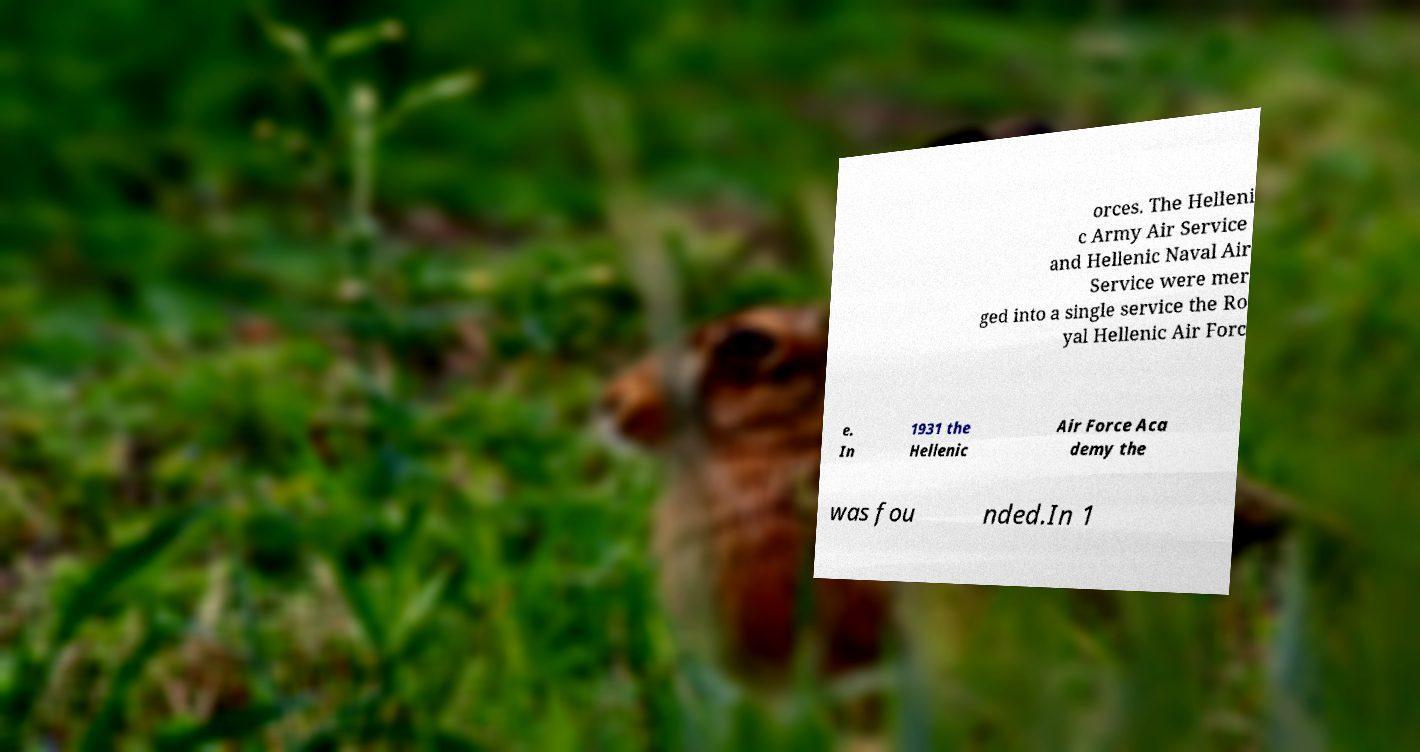Please identify and transcribe the text found in this image. orces. The Helleni c Army Air Service and Hellenic Naval Air Service were mer ged into a single service the Ro yal Hellenic Air Forc e. In 1931 the Hellenic Air Force Aca demy the was fou nded.In 1 